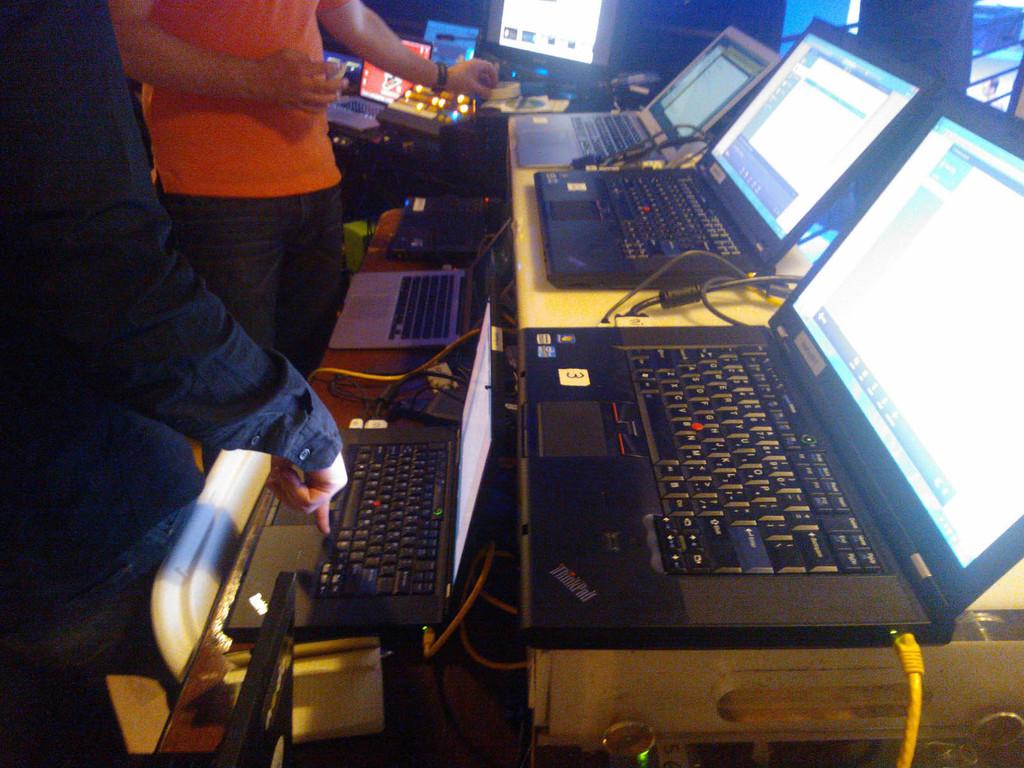What kind of laptop is this?
Offer a very short reply. Unanswerable. 